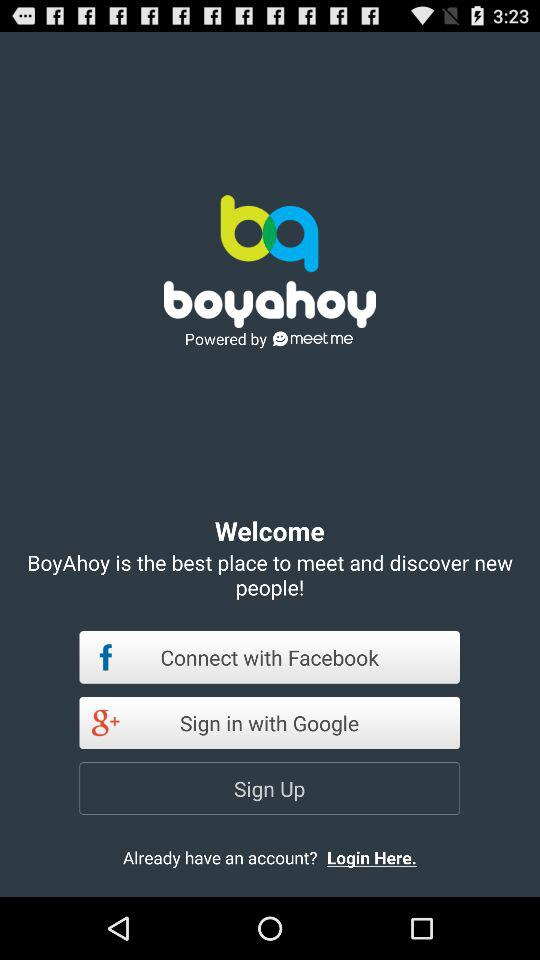How long does it take to sign up?
When the provided information is insufficient, respond with <no answer>. <no answer> 